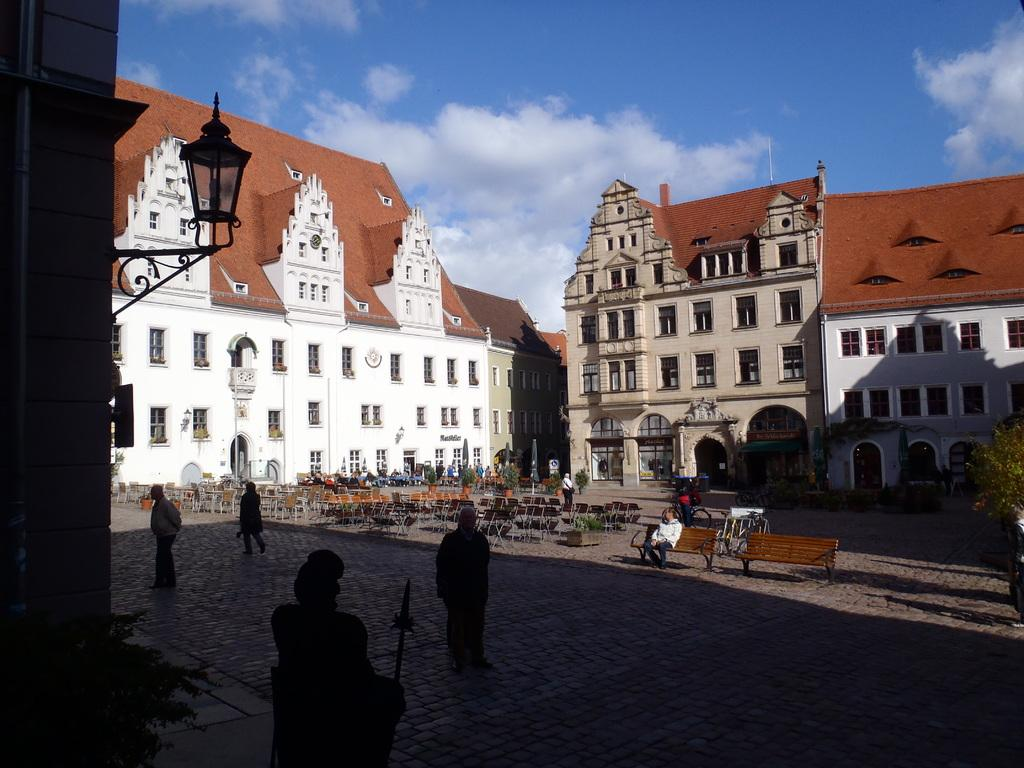What are the people in the image doing? There are persons standing and sitting on benches in the image. What can be seen in the background of the image? There are buildings in the background of the image. What is the condition of the sky in the image? The sky is clear and visible at the top of the image. What type of nail can be seen being hammered into the bench in the image? There is no nail being hammered into the bench in the image. How is the division of space represented in the image? The image does not depict any division of space; it shows people standing and sitting on benches with buildings in the background and a clear sky. 